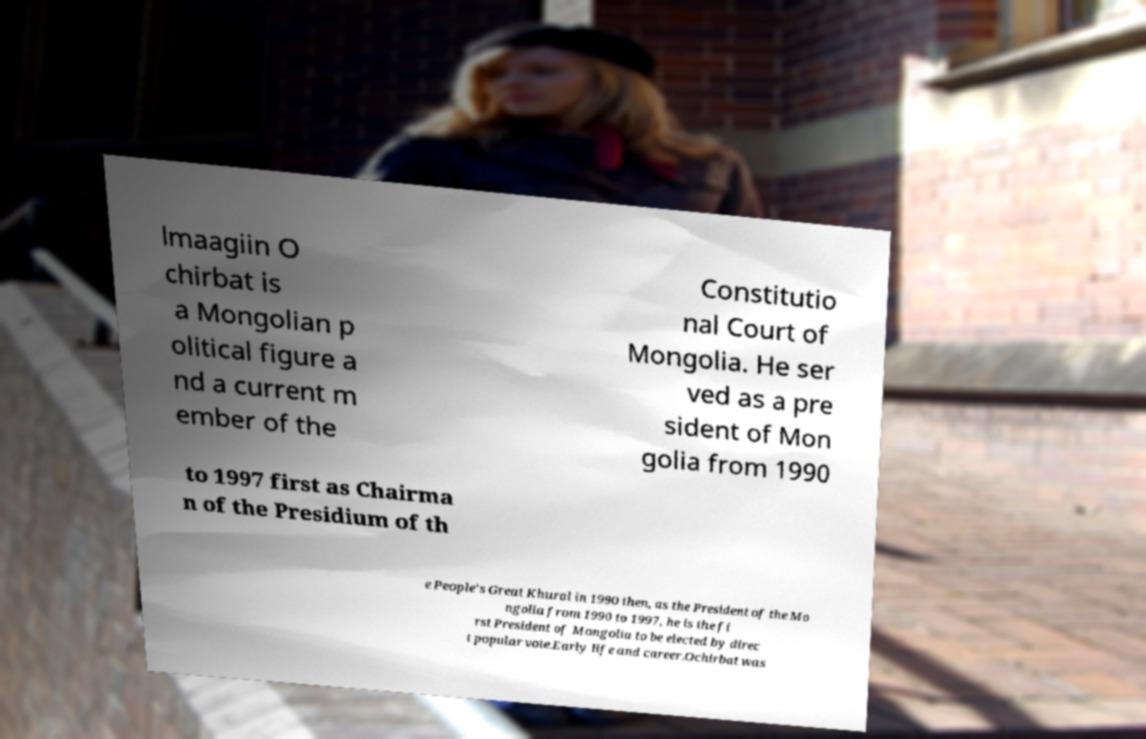What messages or text are displayed in this image? I need them in a readable, typed format. lmaagiin O chirbat is a Mongolian p olitical figure a nd a current m ember of the Constitutio nal Court of Mongolia. He ser ved as a pre sident of Mon golia from 1990 to 1997 first as Chairma n of the Presidium of th e People's Great Khural in 1990 then, as the President of the Mo ngolia from 1990 to 1997, he is the fi rst President of Mongolia to be elected by direc t popular vote.Early life and career.Ochirbat was 